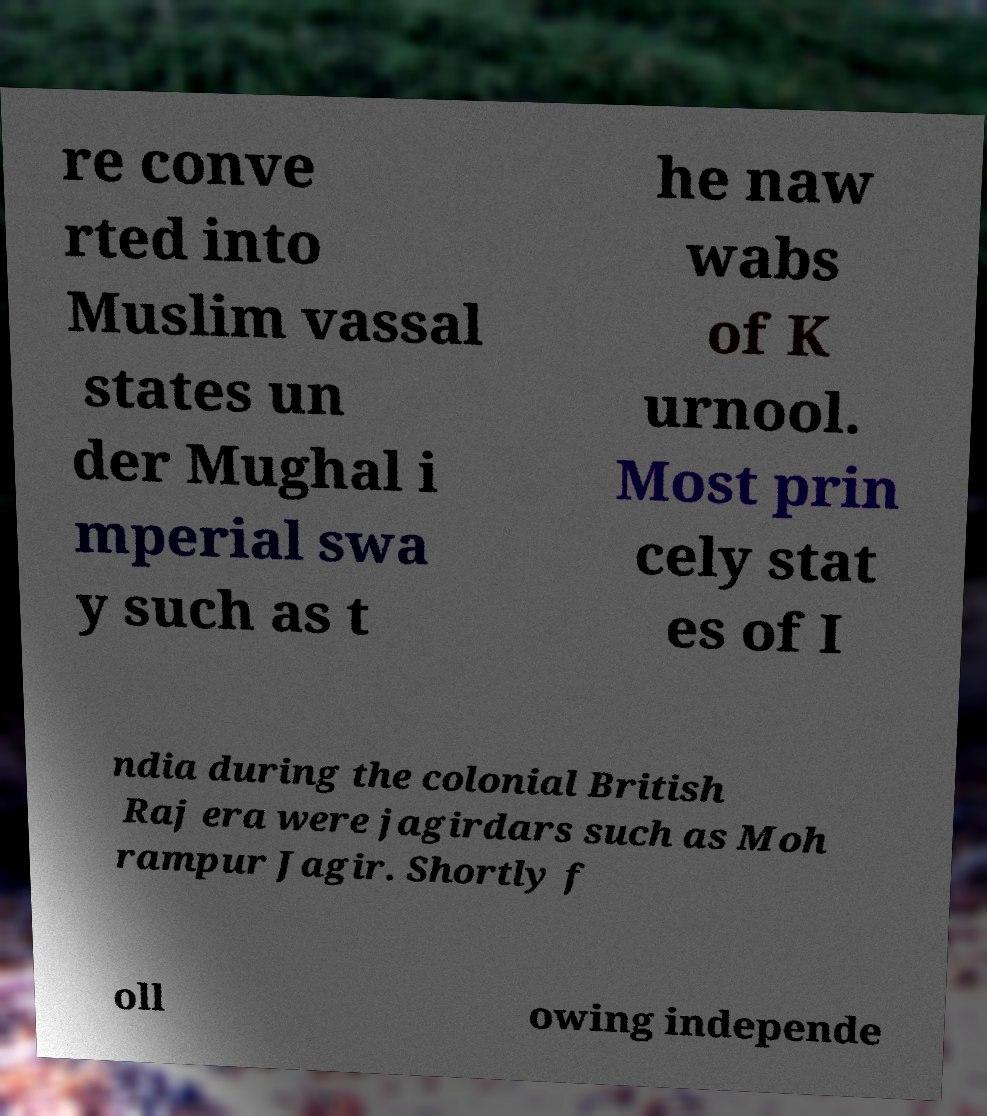Please identify and transcribe the text found in this image. re conve rted into Muslim vassal states un der Mughal i mperial swa y such as t he naw wabs of K urnool. Most prin cely stat es of I ndia during the colonial British Raj era were jagirdars such as Moh rampur Jagir. Shortly f oll owing independe 